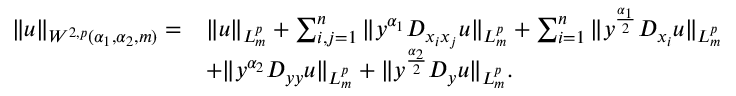<formula> <loc_0><loc_0><loc_500><loc_500>\begin{array} { r l } { \| u \| _ { W ^ { 2 , p } ( \alpha _ { 1 } , \alpha _ { 2 } , m ) } = } & { \| u \| _ { L _ { m } ^ { p } } + \sum _ { i , j = 1 } ^ { n } \| y ^ { \alpha _ { 1 } } D _ { x _ { i } x _ { j } } u \| _ { L _ { m } ^ { p } } + \sum _ { i = 1 } ^ { n } \| y ^ { \frac { \alpha _ { 1 } } 2 } D _ { x _ { i } } u \| _ { L _ { m } ^ { p } } } \\ & { + \| y ^ { \alpha _ { 2 } } D _ { y y } u \| _ { L _ { m } ^ { p } } + \| y ^ { \frac { \alpha _ { 2 } } { 2 } } D _ { y } u \| _ { L _ { m } ^ { p } } . } \end{array}</formula> 